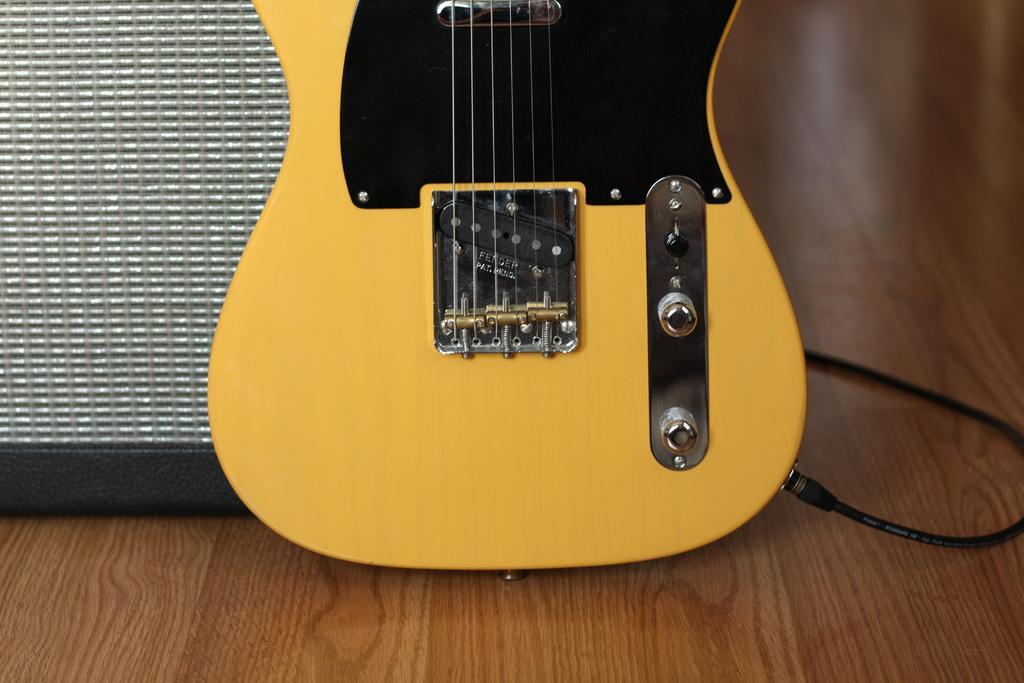Please provide a concise description of this image. In this picture we can see guitar on the wooden floor. On the right there is a black color cable. On the left we can see box. 